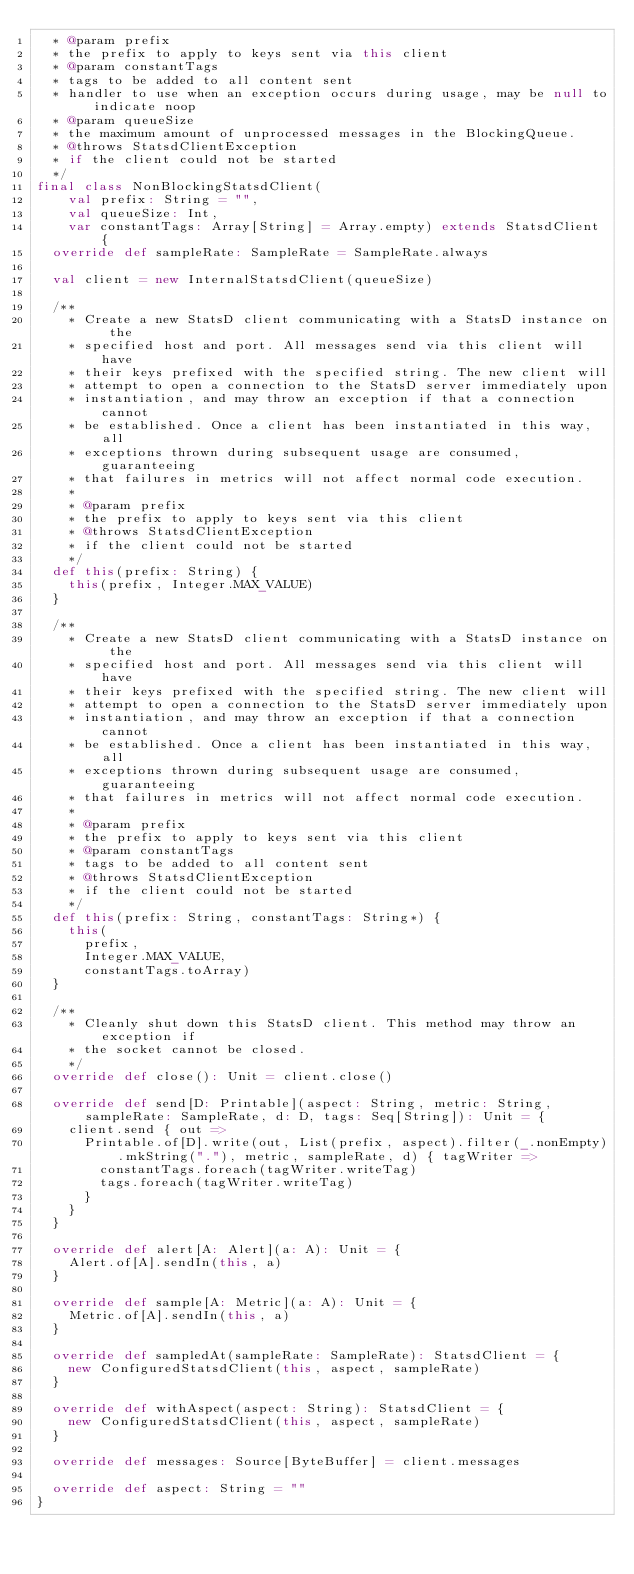<code> <loc_0><loc_0><loc_500><loc_500><_Scala_>  * @param prefix
  * the prefix to apply to keys sent via this client
  * @param constantTags
  * tags to be added to all content sent
  * handler to use when an exception occurs during usage, may be null to indicate noop
  * @param queueSize
  * the maximum amount of unprocessed messages in the BlockingQueue.
  * @throws StatsdClientException
  * if the client could not be started
  */
final class NonBlockingStatsdClient(
    val prefix: String = "",
    val queueSize: Int,
    var constantTags: Array[String] = Array.empty) extends StatsdClient {
  override def sampleRate: SampleRate = SampleRate.always

  val client = new InternalStatsdClient(queueSize)

  /**
    * Create a new StatsD client communicating with a StatsD instance on the
    * specified host and port. All messages send via this client will have
    * their keys prefixed with the specified string. The new client will
    * attempt to open a connection to the StatsD server immediately upon
    * instantiation, and may throw an exception if that a connection cannot
    * be established. Once a client has been instantiated in this way, all
    * exceptions thrown during subsequent usage are consumed, guaranteeing
    * that failures in metrics will not affect normal code execution.
    *
    * @param prefix
    * the prefix to apply to keys sent via this client
    * @throws StatsdClientException
    * if the client could not be started
    */
  def this(prefix: String) {
    this(prefix, Integer.MAX_VALUE)
  }

  /**
    * Create a new StatsD client communicating with a StatsD instance on the
    * specified host and port. All messages send via this client will have
    * their keys prefixed with the specified string. The new client will
    * attempt to open a connection to the StatsD server immediately upon
    * instantiation, and may throw an exception if that a connection cannot
    * be established. Once a client has been instantiated in this way, all
    * exceptions thrown during subsequent usage are consumed, guaranteeing
    * that failures in metrics will not affect normal code execution.
    *
    * @param prefix
    * the prefix to apply to keys sent via this client
    * @param constantTags
    * tags to be added to all content sent
    * @throws StatsdClientException
    * if the client could not be started
    */
  def this(prefix: String, constantTags: String*) {
    this(
      prefix,
      Integer.MAX_VALUE,
      constantTags.toArray)
  }

  /**
    * Cleanly shut down this StatsD client. This method may throw an exception if
    * the socket cannot be closed.
    */
  override def close(): Unit = client.close()

  override def send[D: Printable](aspect: String, metric: String, sampleRate: SampleRate, d: D, tags: Seq[String]): Unit = {
    client.send { out =>
      Printable.of[D].write(out, List(prefix, aspect).filter(_.nonEmpty).mkString("."), metric, sampleRate, d) { tagWriter =>
        constantTags.foreach(tagWriter.writeTag)
        tags.foreach(tagWriter.writeTag)
      }
    }
  }
  
  override def alert[A: Alert](a: A): Unit = {
    Alert.of[A].sendIn(this, a)
  }
  
  override def sample[A: Metric](a: A): Unit = {
    Metric.of[A].sendIn(this, a)
  }

  override def sampledAt(sampleRate: SampleRate): StatsdClient = {
    new ConfiguredStatsdClient(this, aspect, sampleRate)
  }

  override def withAspect(aspect: String): StatsdClient = {
    new ConfiguredStatsdClient(this, aspect, sampleRate)
  }

  override def messages: Source[ByteBuffer] = client.messages

  override def aspect: String = ""
}
</code> 